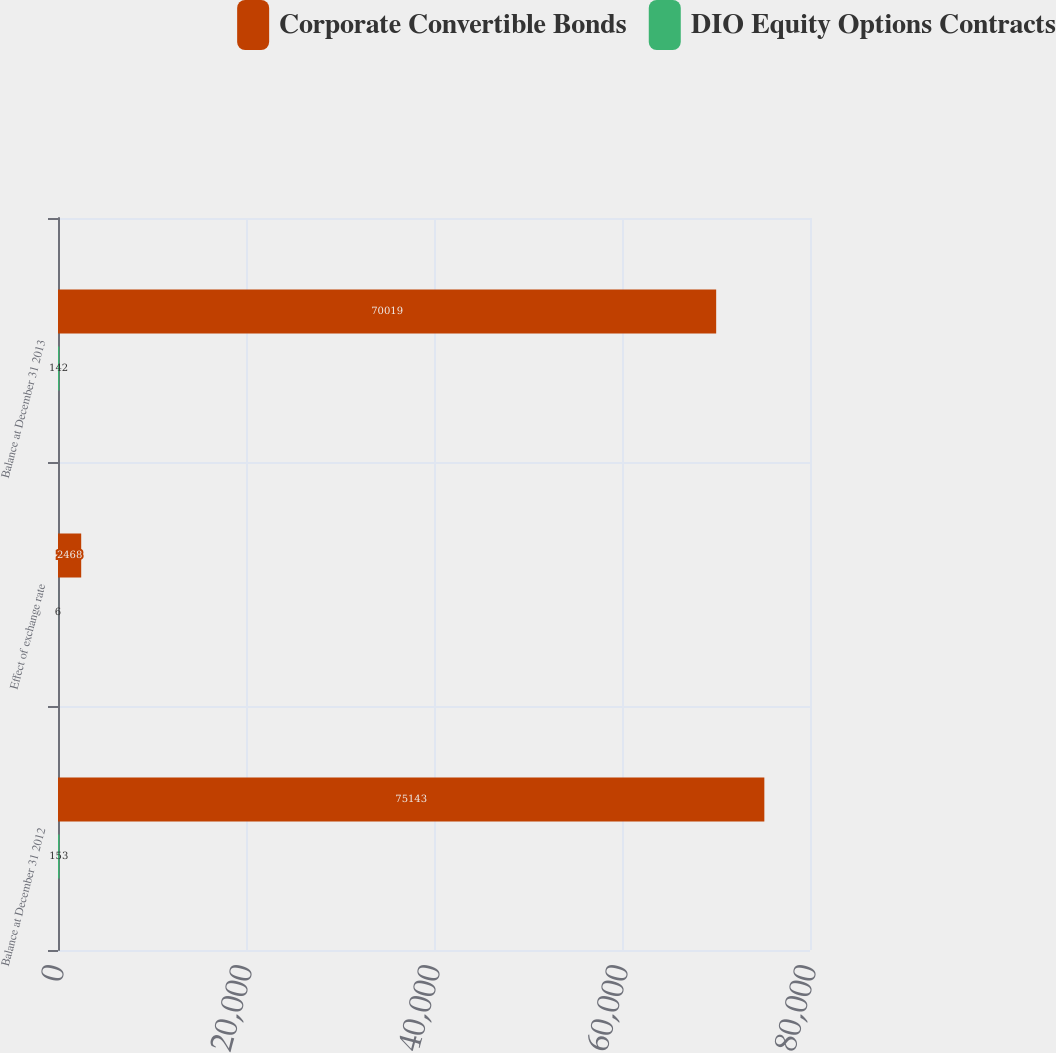Convert chart to OTSL. <chart><loc_0><loc_0><loc_500><loc_500><stacked_bar_chart><ecel><fcel>Balance at December 31 2012<fcel>Effect of exchange rate<fcel>Balance at December 31 2013<nl><fcel>Corporate Convertible Bonds<fcel>75143<fcel>2468<fcel>70019<nl><fcel>DIO Equity Options Contracts<fcel>153<fcel>6<fcel>142<nl></chart> 